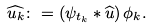Convert formula to latex. <formula><loc_0><loc_0><loc_500><loc_500>\widehat { u _ { k } } \colon = \left ( \psi _ { t _ { k } } \ast \widehat { u } \right ) \phi _ { k } .</formula> 